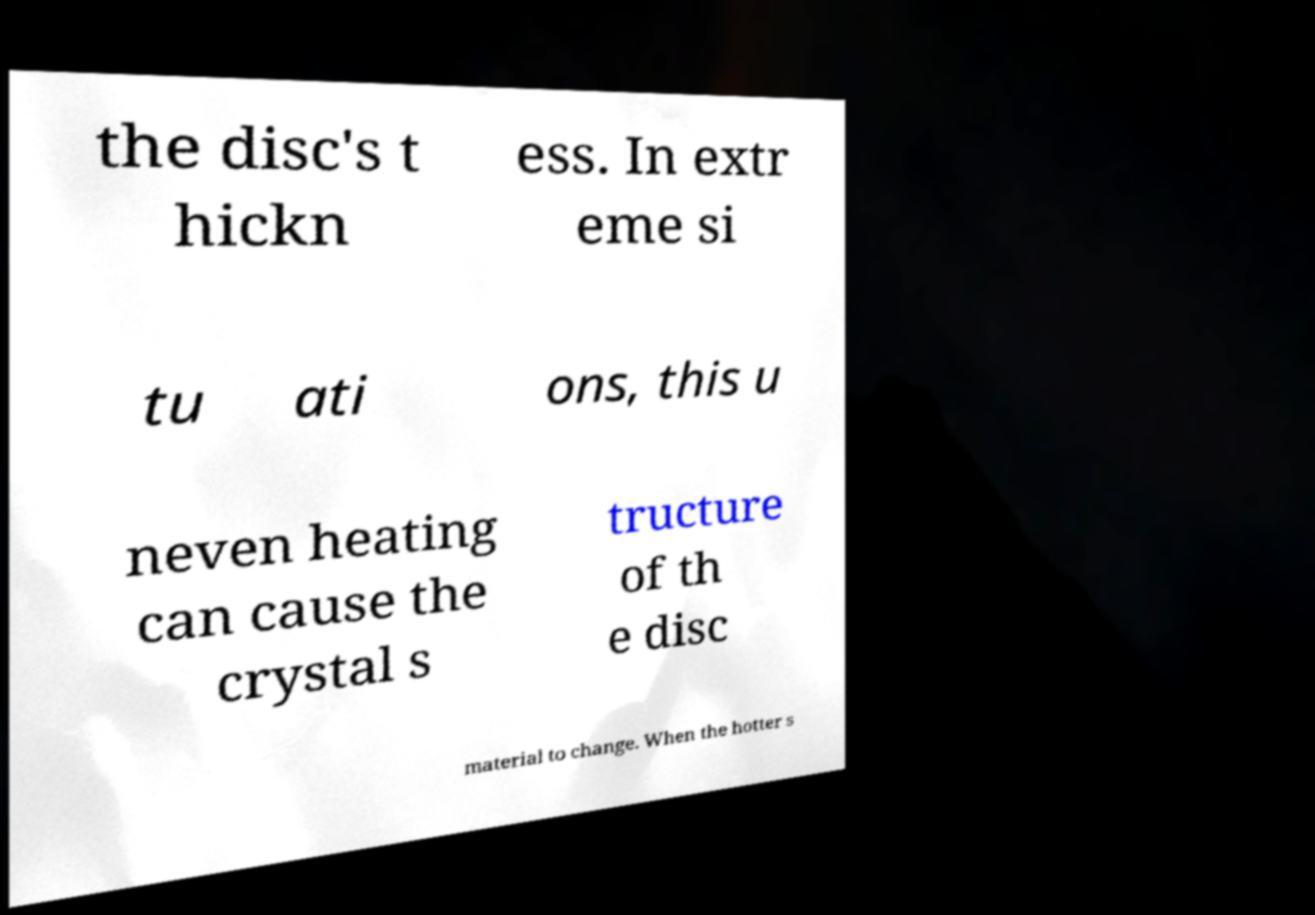Can you read and provide the text displayed in the image?This photo seems to have some interesting text. Can you extract and type it out for me? the disc's t hickn ess. In extr eme si tu ati ons, this u neven heating can cause the crystal s tructure of th e disc material to change. When the hotter s 